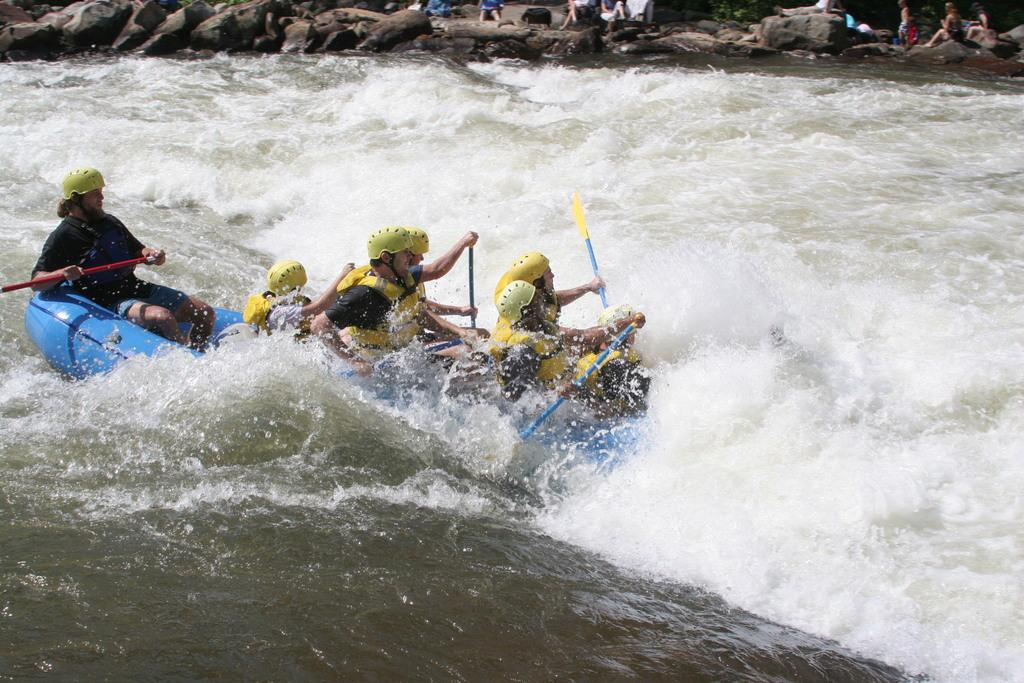Who is present in the image? There are people in the image. What are some of the people doing in the image? Some people are rowing in the image. What natural elements can be seen in the image? There are rocks and trees in the image. What language is being spoken by the people in the image? There is no information about the language being spoken in the image. What is the value of the scissors in the image? There are no scissors present in the image. 